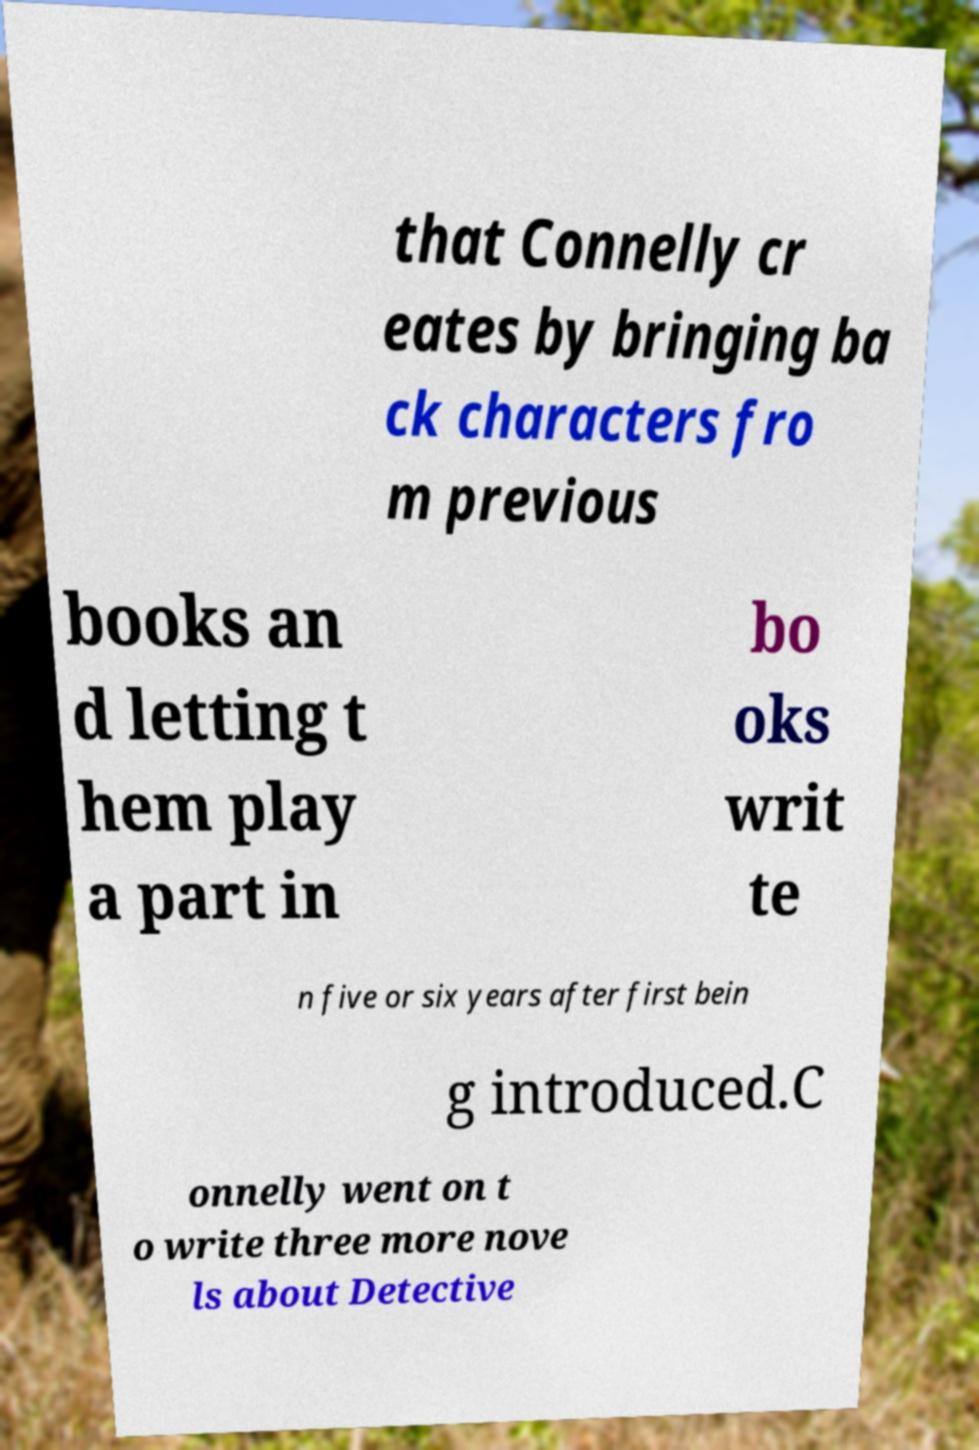Please read and relay the text visible in this image. What does it say? that Connelly cr eates by bringing ba ck characters fro m previous books an d letting t hem play a part in bo oks writ te n five or six years after first bein g introduced.C onnelly went on t o write three more nove ls about Detective 